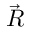<formula> <loc_0><loc_0><loc_500><loc_500>\vec { R }</formula> 